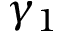Convert formula to latex. <formula><loc_0><loc_0><loc_500><loc_500>\gamma _ { 1 }</formula> 